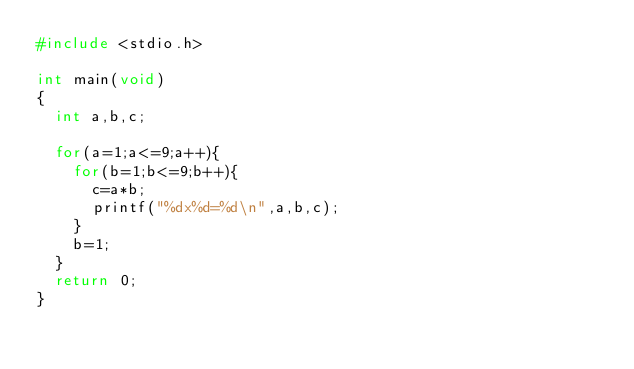Convert code to text. <code><loc_0><loc_0><loc_500><loc_500><_C_>#include <stdio.h>

int main(void)
{
	int a,b,c;
	
	for(a=1;a<=9;a++){
		for(b=1;b<=9;b++){
			c=a*b;
			printf("%dx%d=%d\n",a,b,c);
		}
		b=1;
	}
	return 0;
}</code> 